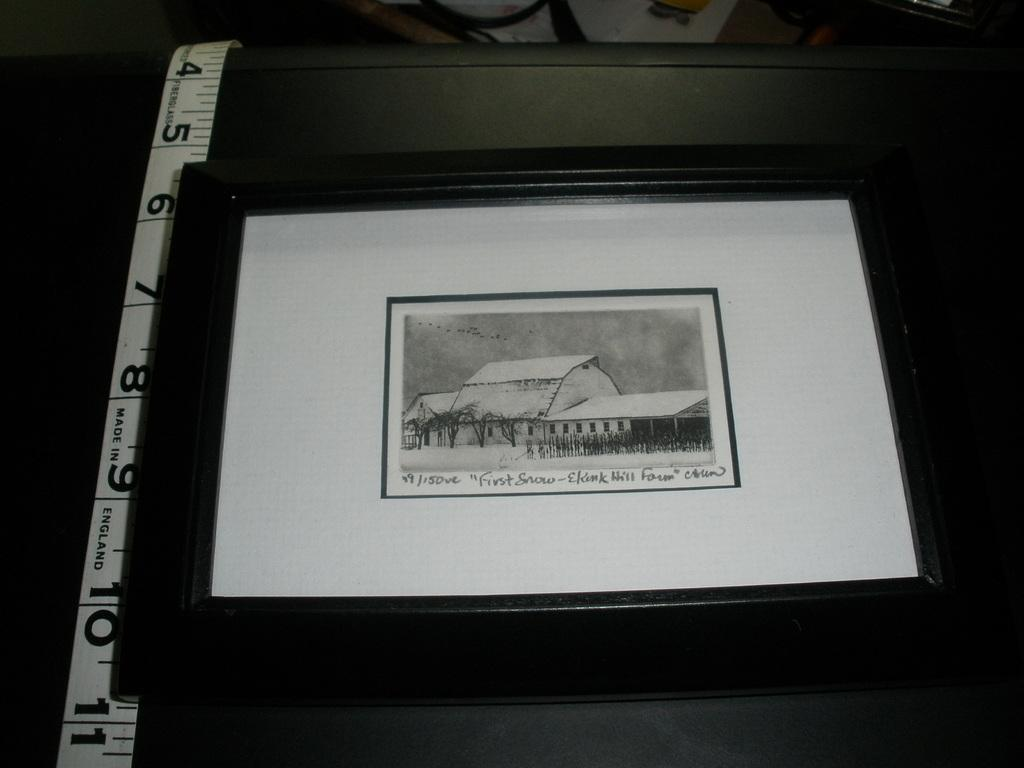<image>
Render a clear and concise summary of the photo. Framed photo showing a house and the words "First snow". 